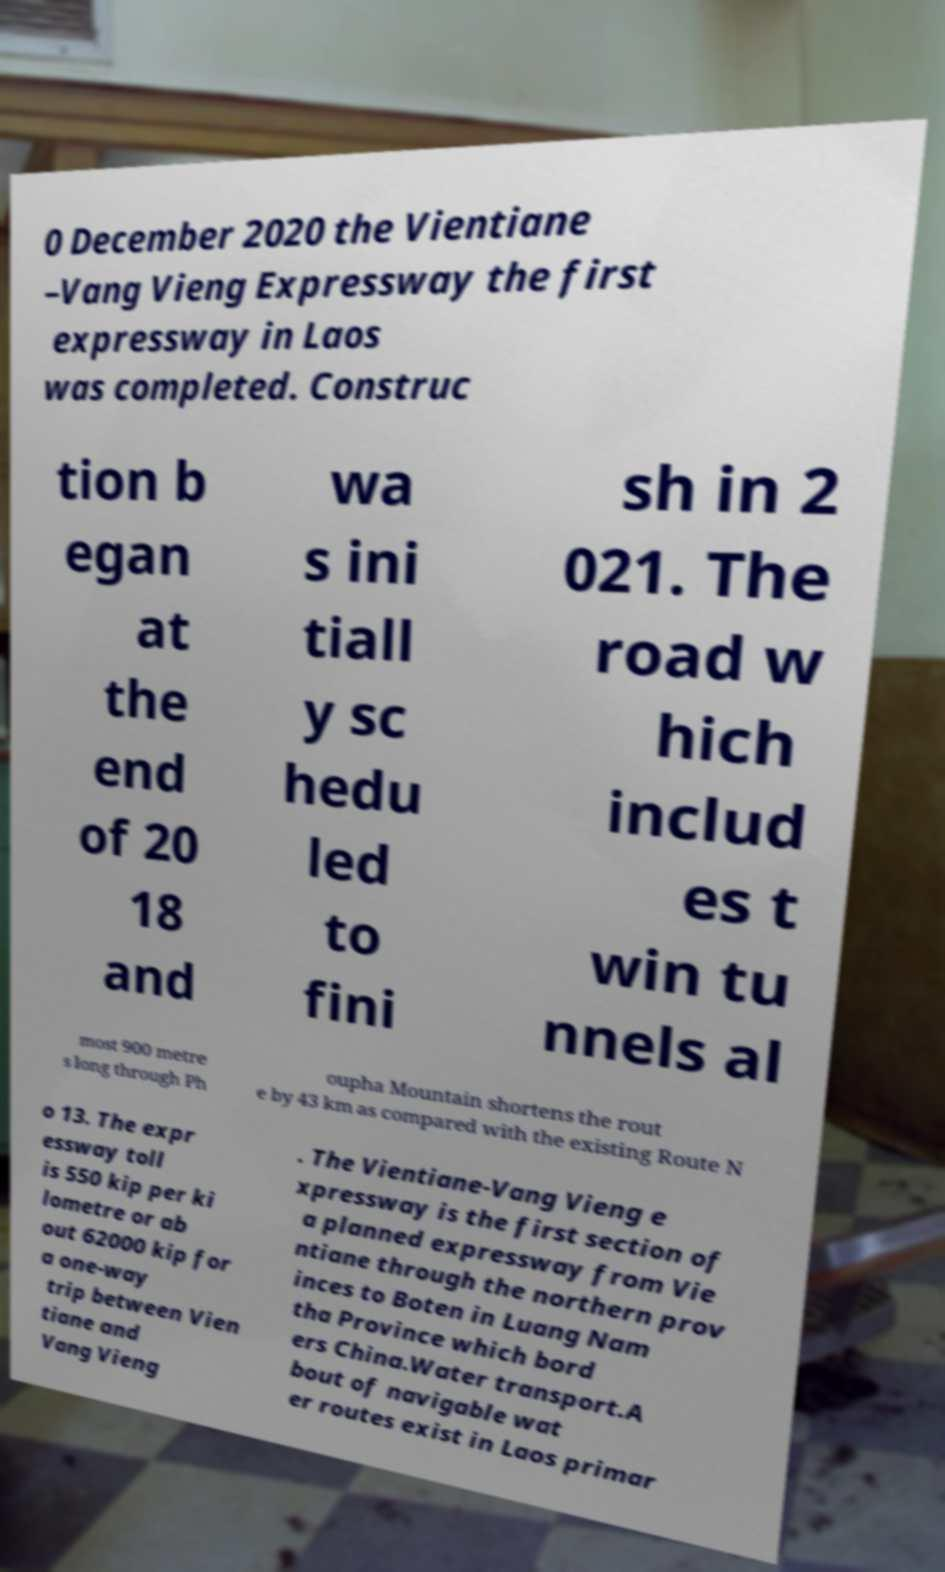Could you assist in decoding the text presented in this image and type it out clearly? 0 December 2020 the Vientiane –Vang Vieng Expressway the first expressway in Laos was completed. Construc tion b egan at the end of 20 18 and wa s ini tiall y sc hedu led to fini sh in 2 021. The road w hich includ es t win tu nnels al most 900 metre s long through Ph oupha Mountain shortens the rout e by 43 km as compared with the existing Route N o 13. The expr essway toll is 550 kip per ki lometre or ab out 62000 kip for a one-way trip between Vien tiane and Vang Vieng . The Vientiane-Vang Vieng e xpressway is the first section of a planned expressway from Vie ntiane through the northern prov inces to Boten in Luang Nam tha Province which bord ers China.Water transport.A bout of navigable wat er routes exist in Laos primar 